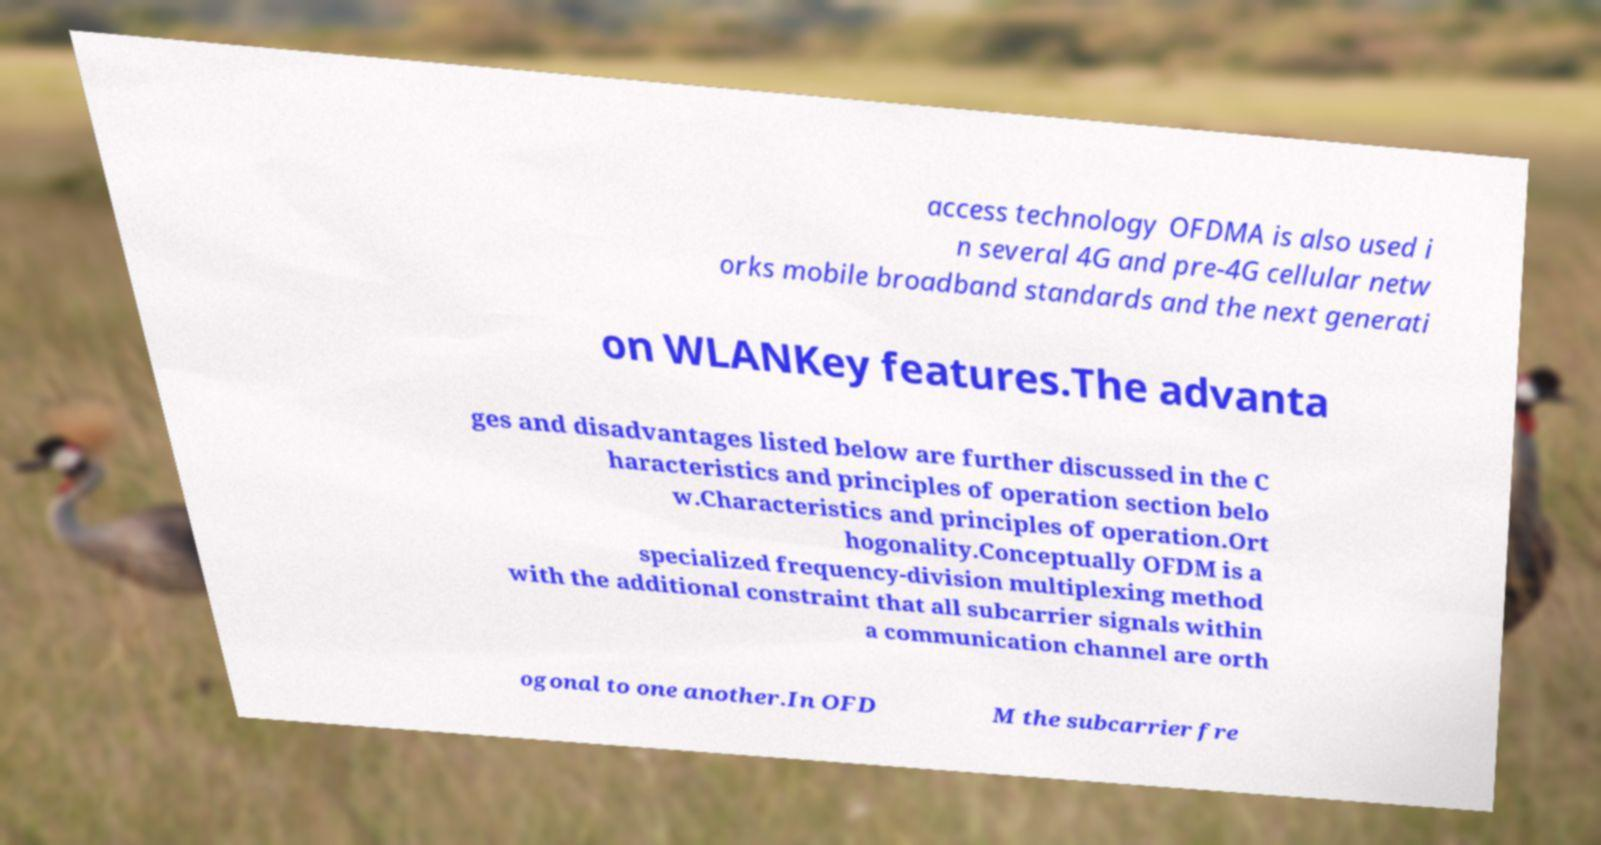Please identify and transcribe the text found in this image. access technology OFDMA is also used i n several 4G and pre-4G cellular netw orks mobile broadband standards and the next generati on WLANKey features.The advanta ges and disadvantages listed below are further discussed in the C haracteristics and principles of operation section belo w.Characteristics and principles of operation.Ort hogonality.Conceptually OFDM is a specialized frequency-division multiplexing method with the additional constraint that all subcarrier signals within a communication channel are orth ogonal to one another.In OFD M the subcarrier fre 